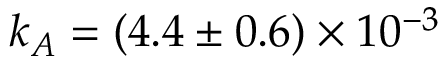Convert formula to latex. <formula><loc_0><loc_0><loc_500><loc_500>k _ { A } = ( 4 . 4 \pm 0 . 6 ) \times 1 0 ^ { - 3 }</formula> 